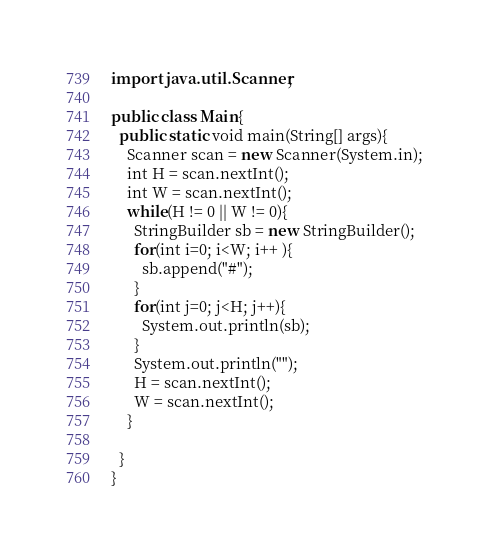Convert code to text. <code><loc_0><loc_0><loc_500><loc_500><_Java_>import java.util.Scanner;

public class Main{
  public static void main(String[] args){
    Scanner scan = new Scanner(System.in);
    int H = scan.nextInt();
    int W = scan.nextInt();
    while(H != 0 || W != 0){
      StringBuilder sb = new StringBuilder();
      for(int i=0; i<W; i++ ){
        sb.append("#");
      }
      for(int j=0; j<H; j++){
        System.out.println(sb);
      }
      System.out.println("");
      H = scan.nextInt();
      W = scan.nextInt();
    }
    
  }
}</code> 